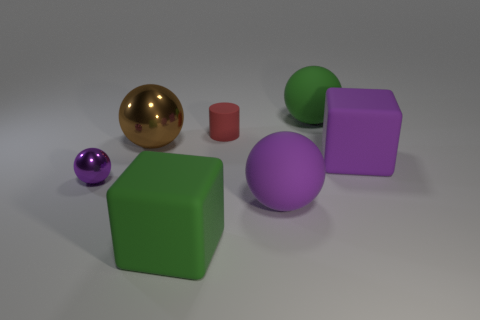Add 1 large brown metal spheres. How many objects exist? 8 Subtract all spheres. How many objects are left? 3 Subtract all large yellow metallic cylinders. Subtract all balls. How many objects are left? 3 Add 3 big rubber things. How many big rubber things are left? 7 Add 6 tiny purple matte cubes. How many tiny purple matte cubes exist? 6 Subtract 0 cyan cubes. How many objects are left? 7 